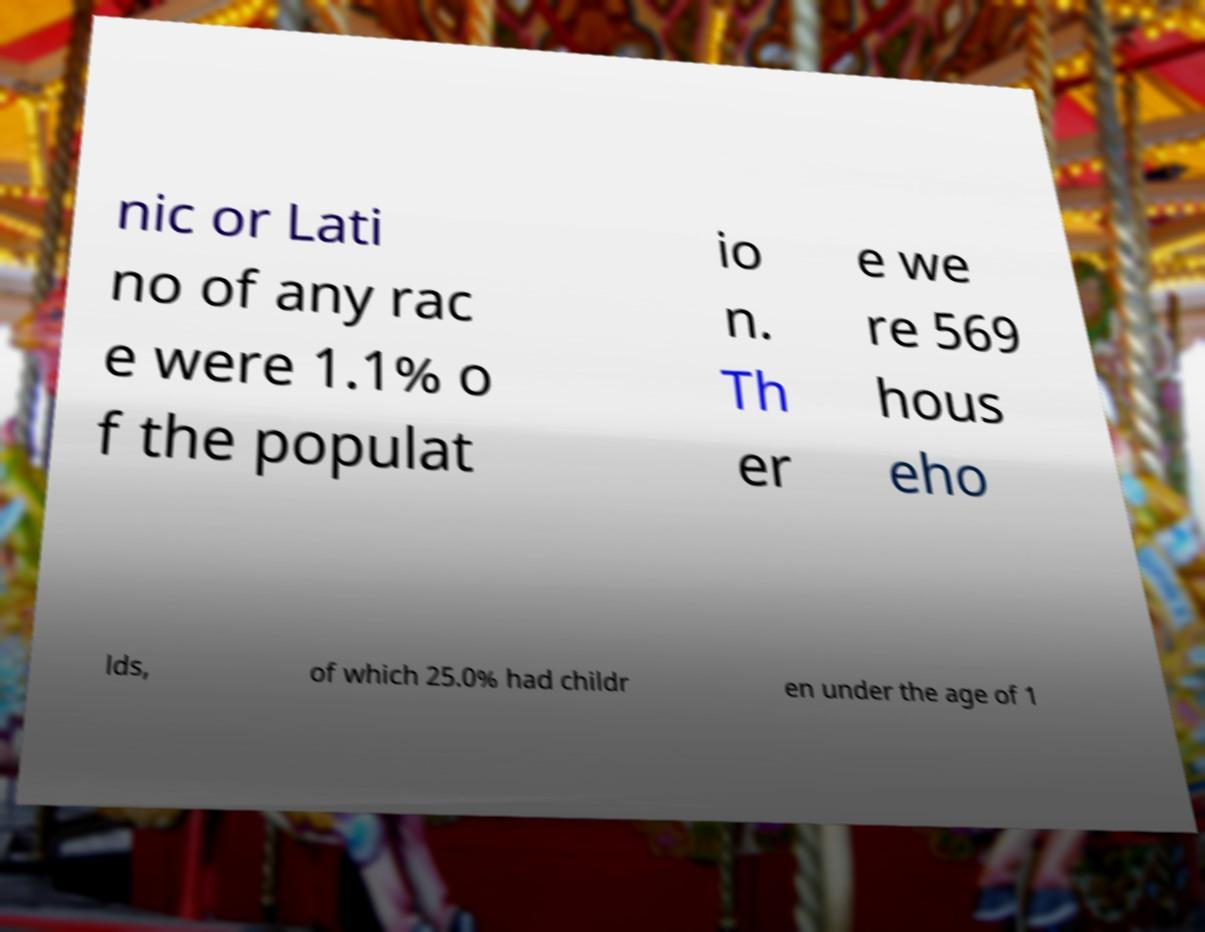There's text embedded in this image that I need extracted. Can you transcribe it verbatim? nic or Lati no of any rac e were 1.1% o f the populat io n. Th er e we re 569 hous eho lds, of which 25.0% had childr en under the age of 1 